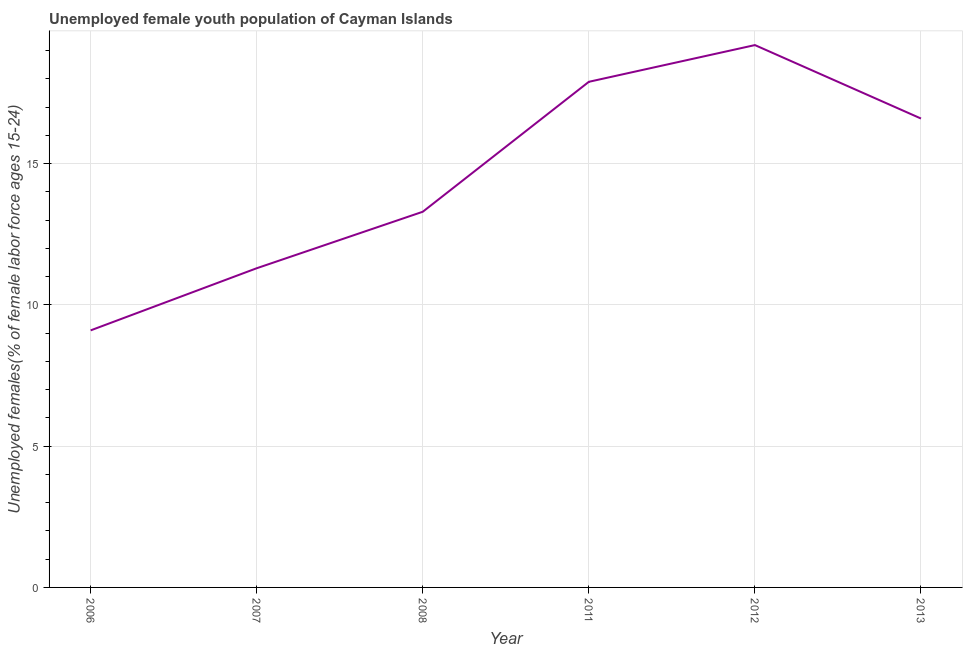What is the unemployed female youth in 2006?
Give a very brief answer. 9.1. Across all years, what is the maximum unemployed female youth?
Offer a terse response. 19.2. Across all years, what is the minimum unemployed female youth?
Provide a short and direct response. 9.1. In which year was the unemployed female youth maximum?
Provide a short and direct response. 2012. In which year was the unemployed female youth minimum?
Keep it short and to the point. 2006. What is the sum of the unemployed female youth?
Make the answer very short. 87.4. What is the difference between the unemployed female youth in 2012 and 2013?
Offer a terse response. 2.6. What is the average unemployed female youth per year?
Your response must be concise. 14.57. What is the median unemployed female youth?
Keep it short and to the point. 14.95. In how many years, is the unemployed female youth greater than 1 %?
Your answer should be compact. 6. What is the ratio of the unemployed female youth in 2012 to that in 2013?
Offer a terse response. 1.16. Is the unemployed female youth in 2011 less than that in 2012?
Keep it short and to the point. Yes. What is the difference between the highest and the second highest unemployed female youth?
Provide a short and direct response. 1.3. Is the sum of the unemployed female youth in 2006 and 2007 greater than the maximum unemployed female youth across all years?
Your answer should be very brief. Yes. What is the difference between the highest and the lowest unemployed female youth?
Make the answer very short. 10.1. In how many years, is the unemployed female youth greater than the average unemployed female youth taken over all years?
Ensure brevity in your answer.  3. How many years are there in the graph?
Give a very brief answer. 6. What is the difference between two consecutive major ticks on the Y-axis?
Offer a very short reply. 5. Are the values on the major ticks of Y-axis written in scientific E-notation?
Make the answer very short. No. Does the graph contain any zero values?
Offer a terse response. No. Does the graph contain grids?
Your answer should be very brief. Yes. What is the title of the graph?
Keep it short and to the point. Unemployed female youth population of Cayman Islands. What is the label or title of the Y-axis?
Make the answer very short. Unemployed females(% of female labor force ages 15-24). What is the Unemployed females(% of female labor force ages 15-24) of 2006?
Your response must be concise. 9.1. What is the Unemployed females(% of female labor force ages 15-24) of 2007?
Give a very brief answer. 11.3. What is the Unemployed females(% of female labor force ages 15-24) in 2008?
Provide a short and direct response. 13.3. What is the Unemployed females(% of female labor force ages 15-24) of 2011?
Your answer should be very brief. 17.9. What is the Unemployed females(% of female labor force ages 15-24) in 2012?
Provide a short and direct response. 19.2. What is the Unemployed females(% of female labor force ages 15-24) in 2013?
Your response must be concise. 16.6. What is the difference between the Unemployed females(% of female labor force ages 15-24) in 2006 and 2011?
Ensure brevity in your answer.  -8.8. What is the difference between the Unemployed females(% of female labor force ages 15-24) in 2007 and 2008?
Offer a very short reply. -2. What is the difference between the Unemployed females(% of female labor force ages 15-24) in 2007 and 2011?
Your answer should be very brief. -6.6. What is the difference between the Unemployed females(% of female labor force ages 15-24) in 2007 and 2012?
Offer a very short reply. -7.9. What is the difference between the Unemployed females(% of female labor force ages 15-24) in 2007 and 2013?
Provide a short and direct response. -5.3. What is the difference between the Unemployed females(% of female labor force ages 15-24) in 2008 and 2013?
Ensure brevity in your answer.  -3.3. What is the difference between the Unemployed females(% of female labor force ages 15-24) in 2012 and 2013?
Make the answer very short. 2.6. What is the ratio of the Unemployed females(% of female labor force ages 15-24) in 2006 to that in 2007?
Ensure brevity in your answer.  0.81. What is the ratio of the Unemployed females(% of female labor force ages 15-24) in 2006 to that in 2008?
Give a very brief answer. 0.68. What is the ratio of the Unemployed females(% of female labor force ages 15-24) in 2006 to that in 2011?
Your answer should be very brief. 0.51. What is the ratio of the Unemployed females(% of female labor force ages 15-24) in 2006 to that in 2012?
Make the answer very short. 0.47. What is the ratio of the Unemployed females(% of female labor force ages 15-24) in 2006 to that in 2013?
Your response must be concise. 0.55. What is the ratio of the Unemployed females(% of female labor force ages 15-24) in 2007 to that in 2011?
Provide a succinct answer. 0.63. What is the ratio of the Unemployed females(% of female labor force ages 15-24) in 2007 to that in 2012?
Offer a very short reply. 0.59. What is the ratio of the Unemployed females(% of female labor force ages 15-24) in 2007 to that in 2013?
Make the answer very short. 0.68. What is the ratio of the Unemployed females(% of female labor force ages 15-24) in 2008 to that in 2011?
Your answer should be very brief. 0.74. What is the ratio of the Unemployed females(% of female labor force ages 15-24) in 2008 to that in 2012?
Make the answer very short. 0.69. What is the ratio of the Unemployed females(% of female labor force ages 15-24) in 2008 to that in 2013?
Keep it short and to the point. 0.8. What is the ratio of the Unemployed females(% of female labor force ages 15-24) in 2011 to that in 2012?
Give a very brief answer. 0.93. What is the ratio of the Unemployed females(% of female labor force ages 15-24) in 2011 to that in 2013?
Your answer should be very brief. 1.08. What is the ratio of the Unemployed females(% of female labor force ages 15-24) in 2012 to that in 2013?
Your answer should be very brief. 1.16. 